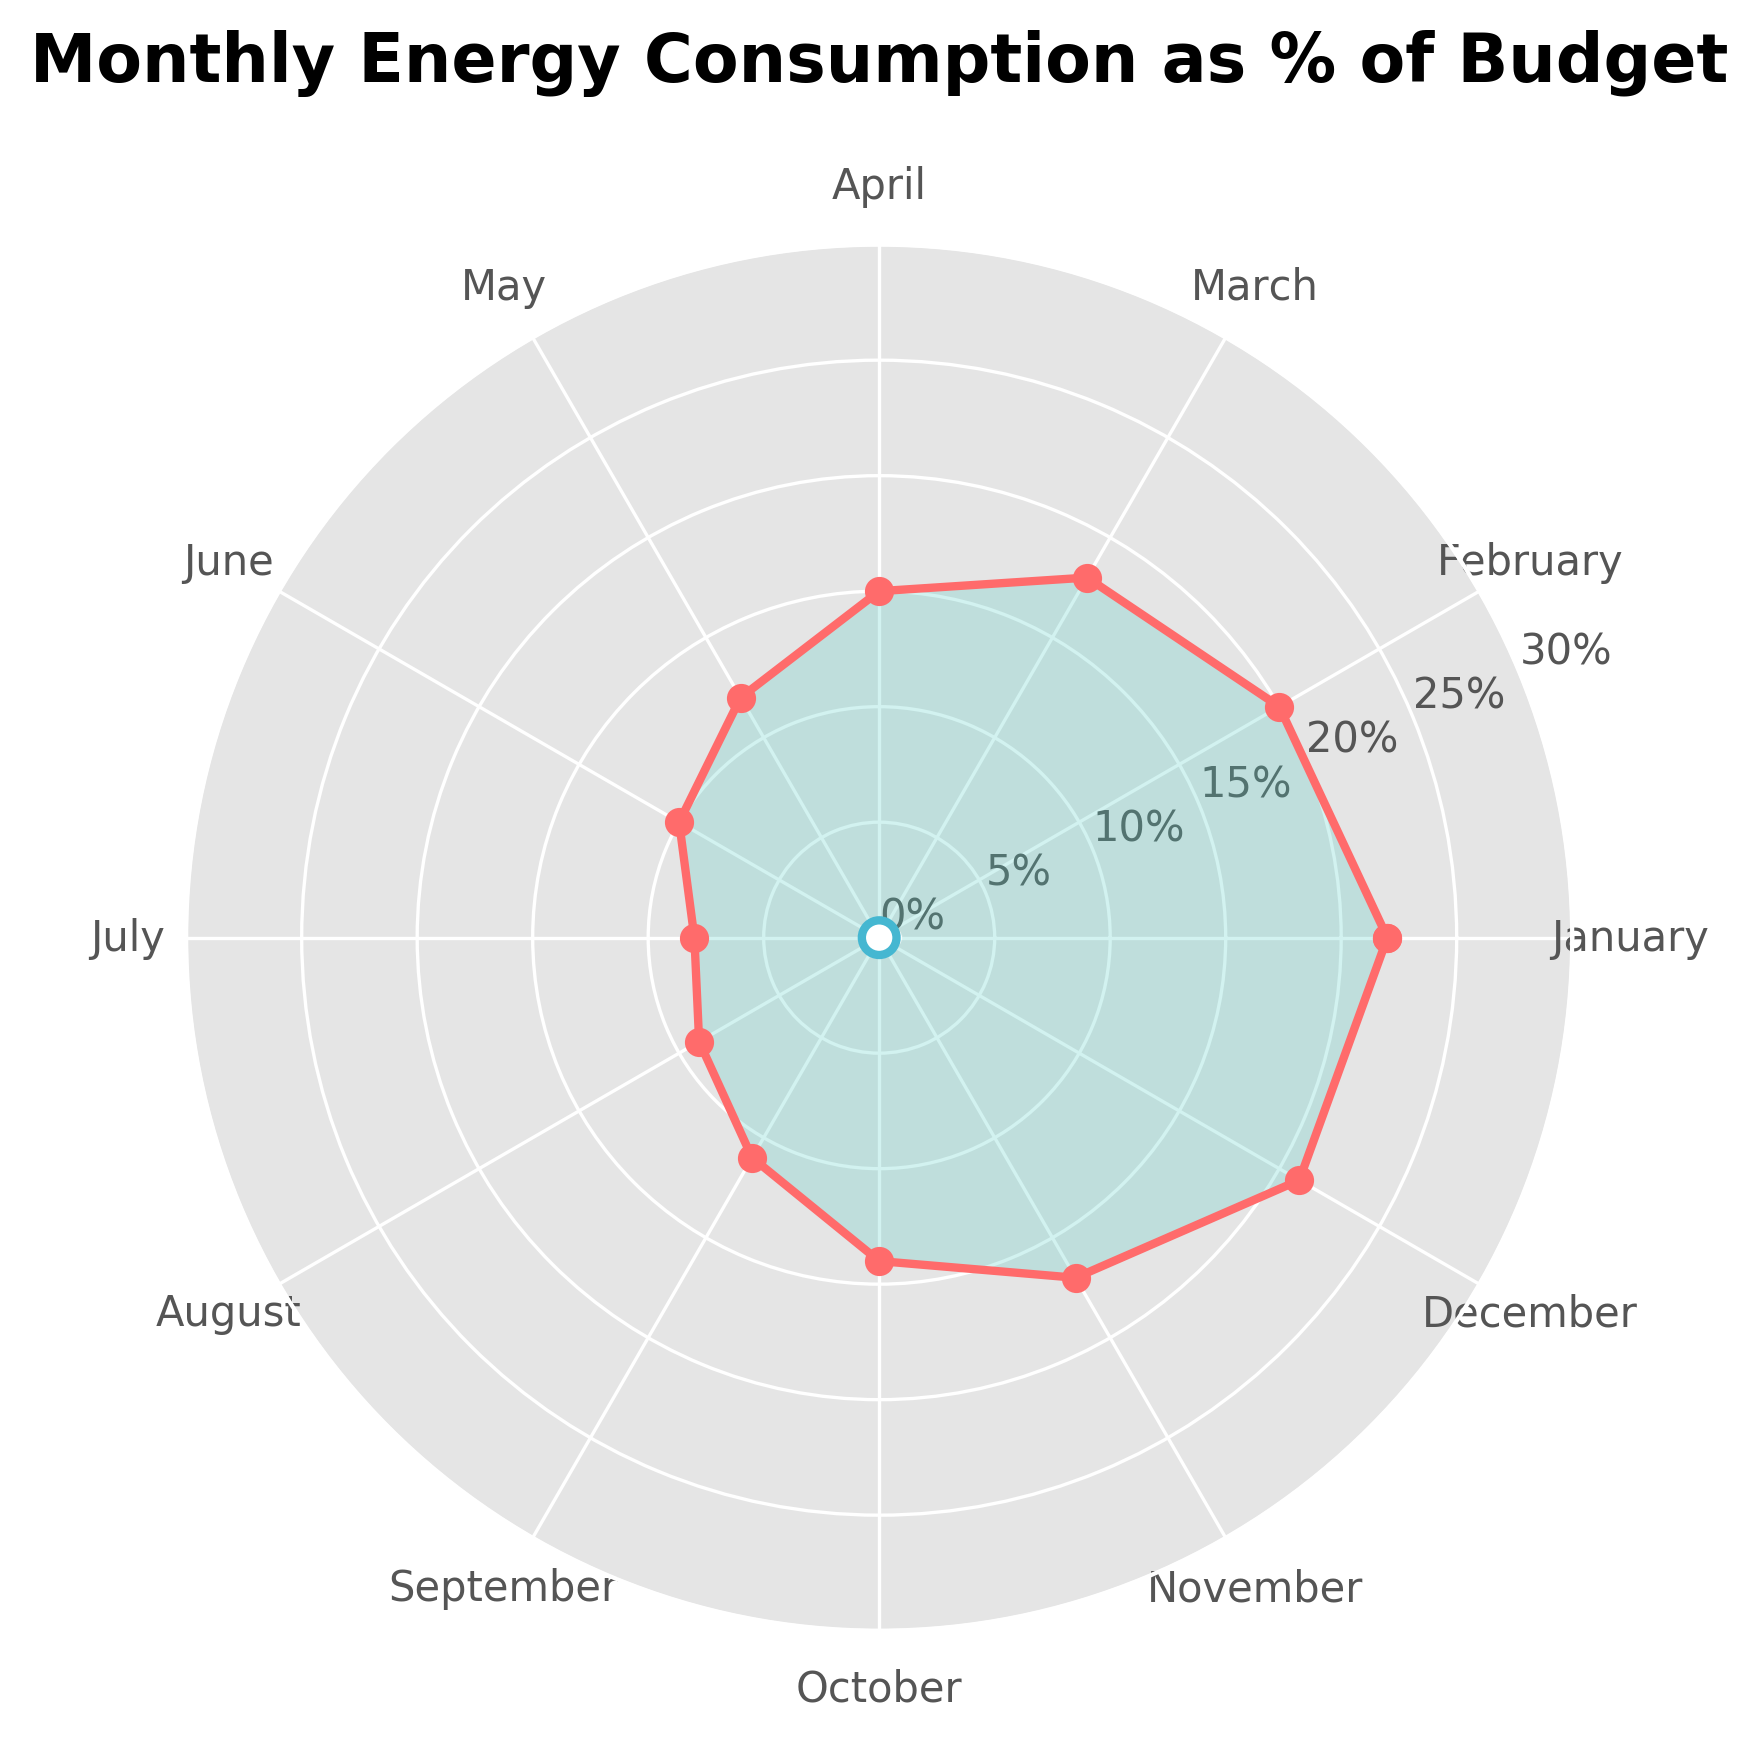What's the title of the figure? The title of the figure can be found at the top. It reads "Monthly Energy Consumption as % of Budget".
Answer: Monthly Energy Consumption as % of Budget How many months have an energy consumption percentage equal to or above 20%? You need to identify the months whose values are 20% or higher. January, February, and December have percentages of 22%, 20%, and 21% respectively.
Answer: 3 In which month is the energy consumption the lowest? You need to locate the month with the smallest percentage value. July shows the lowest energy consumption at 8%.
Answer: July What's the average energy consumption percentage across all months? Sum the given percentages and divide by the total number of months (12). The sum is 22 + 20 + 18 + 15 + 12 + 10 + 8 + 9 + 11 + 14 + 17 + 21 = 177. The average is 177/12.
Answer: 14.75% Is there a month where the energy consumption is exactly 15%? Check if any month's energy consumption is exactly 15%. April shows an exact value of 15%.
Answer: April Which month has a higher energy consumption, November or May? By how much? Compare the energy consumption between November (17%) and May (12%). Subtract the smaller value from the larger value. 17% - 12% = 5%.
Answer: November by 5% What’s the total energy consumption percentage for February, March, and April combined? Add the percentages for these three months: February (20%), March (18%), and April (15%). The sum is 20 + 18 + 15.
Answer: 53% Between which two consecutive months is the largest drop in energy consumption? Compare the drops between every consecutive month and find the largest one. April (15%) to May (12%) is the largest drop: 15% - 12% = 3%.
Answer: April to May What are the two months with the closest energy consumption percentages? Look for the smallest difference between any two months' percentages and identify those months. June and July have 10% and 8%, respectively. The difference is 2%.
Answer: June and July In which quarter (3-month period) is the average energy consumption the highest? Divide the year into quarters and calculate their averages: Q1 (Jan, Feb, Mar): (22 + 20 + 18)/3 = 20%, Q2 (Apr, May, Jun): (15 + 12 + 10)/3 = 12.33%, Q3 (Jul, Aug, Sep): (8 + 9 + 11)/3 = 9.33%, Q4 (Oct, Nov, Dec): (14 + 17 + 21)/3 = 17.33%. Q1 has the highest average.
Answer: Q1 